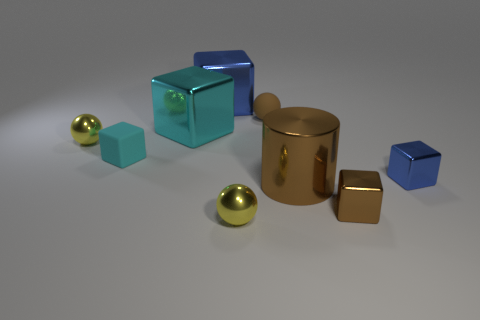Subtract all brown blocks. How many blocks are left? 4 Subtract all cyan matte blocks. How many blocks are left? 4 Subtract 2 cubes. How many cubes are left? 3 Subtract all yellow blocks. Subtract all purple spheres. How many blocks are left? 5 Add 1 small metal blocks. How many objects exist? 10 Subtract all cubes. How many objects are left? 4 Subtract 0 red cylinders. How many objects are left? 9 Subtract all small rubber things. Subtract all balls. How many objects are left? 4 Add 4 matte cubes. How many matte cubes are left? 5 Add 8 cyan matte blocks. How many cyan matte blocks exist? 9 